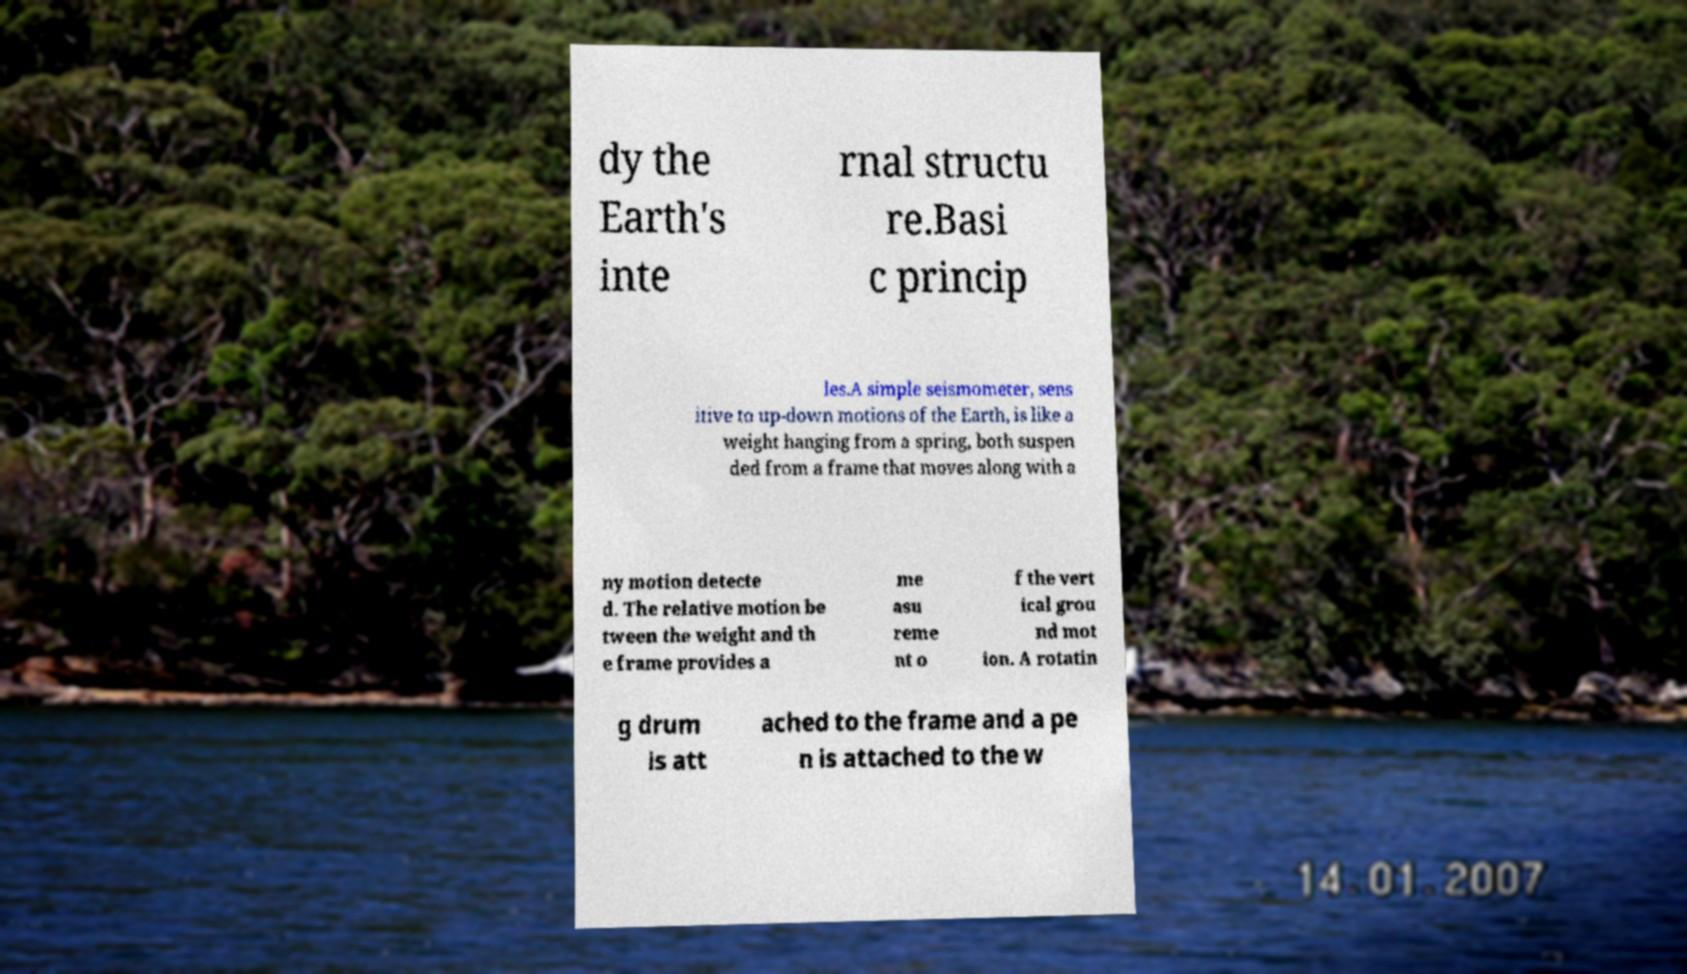Could you extract and type out the text from this image? dy the Earth's inte rnal structu re.Basi c princip les.A simple seismometer, sens itive to up-down motions of the Earth, is like a weight hanging from a spring, both suspen ded from a frame that moves along with a ny motion detecte d. The relative motion be tween the weight and th e frame provides a me asu reme nt o f the vert ical grou nd mot ion. A rotatin g drum is att ached to the frame and a pe n is attached to the w 